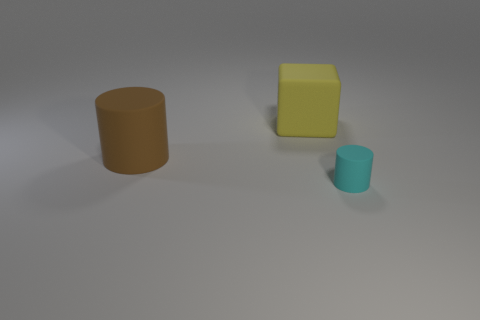How many large objects are brown matte cylinders or yellow matte cylinders?
Give a very brief answer. 1. There is a cube; are there any large rubber blocks in front of it?
Your answer should be compact. No. There is a matte object that is behind the matte cylinder left of the cyan matte object; what is its size?
Provide a succinct answer. Large. Is the number of objects to the right of the cyan cylinder the same as the number of large brown things that are in front of the yellow block?
Offer a terse response. No. There is a object that is behind the large brown matte object; are there any matte cylinders on the right side of it?
Your response must be concise. Yes. What number of large matte things are on the left side of the cylinder on the left side of the object behind the brown object?
Offer a very short reply. 0. Are there fewer large yellow matte blocks than tiny blue cubes?
Provide a short and direct response. No. Does the big thing on the left side of the large yellow matte object have the same shape as the large object that is to the right of the big brown thing?
Provide a succinct answer. No. The small rubber cylinder is what color?
Give a very brief answer. Cyan. How many metal objects are either blocks or large cylinders?
Keep it short and to the point. 0. 